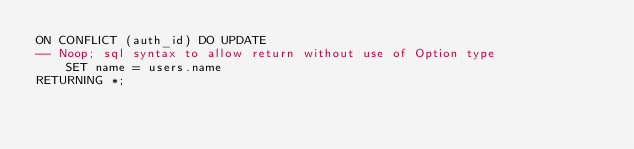Convert code to text. <code><loc_0><loc_0><loc_500><loc_500><_SQL_>ON CONFLICT (auth_id) DO UPDATE
-- Noop; sql syntax to allow return without use of Option type
    SET name = users.name
RETURNING *;
</code> 